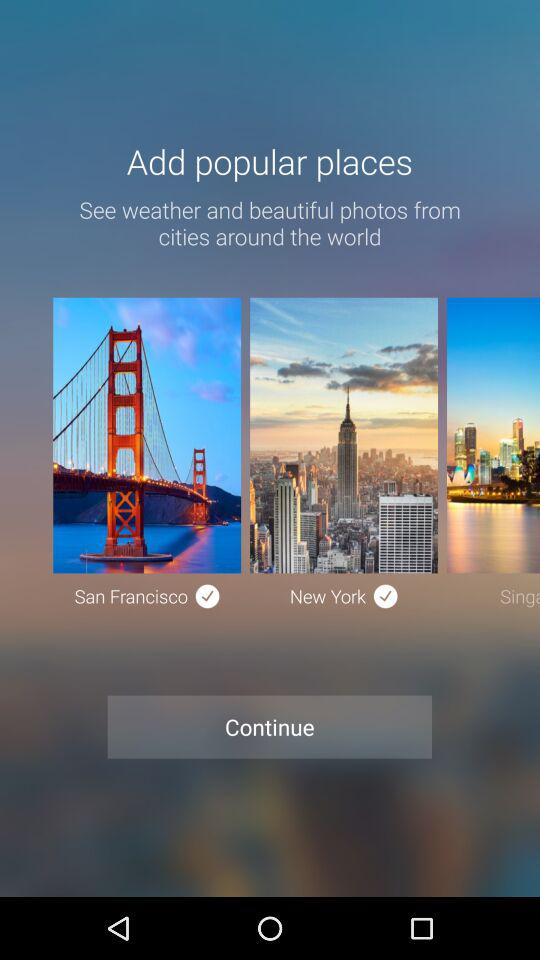How many cities have a check mark next to them?
Answer the question using a single word or phrase. 2 